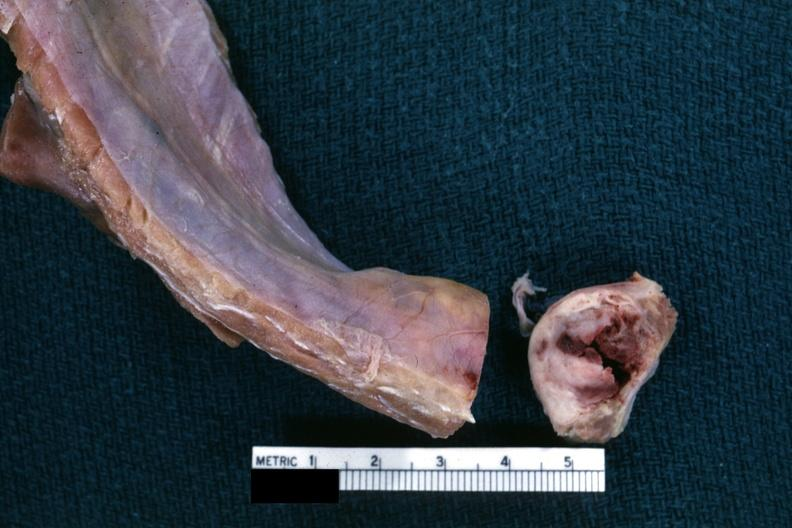s absence of palpebral fissure cleft palate sectioned to show white neoplasm with central hemorrhage?
Answer the question using a single word or phrase. No 